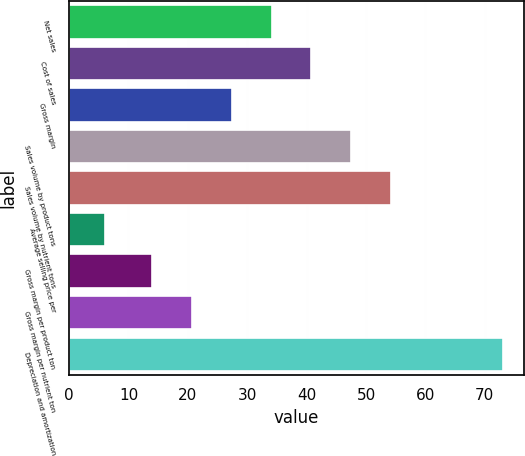<chart> <loc_0><loc_0><loc_500><loc_500><bar_chart><fcel>Net sales<fcel>Cost of sales<fcel>Gross margin<fcel>Sales volume by product tons<fcel>Sales volume by nutrient tons<fcel>Average selling price per<fcel>Gross margin per product ton<fcel>Gross margin per nutrient ton<fcel>Depreciation and amortization<nl><fcel>34.1<fcel>40.8<fcel>27.4<fcel>47.5<fcel>54.2<fcel>6<fcel>14<fcel>20.7<fcel>73<nl></chart> 